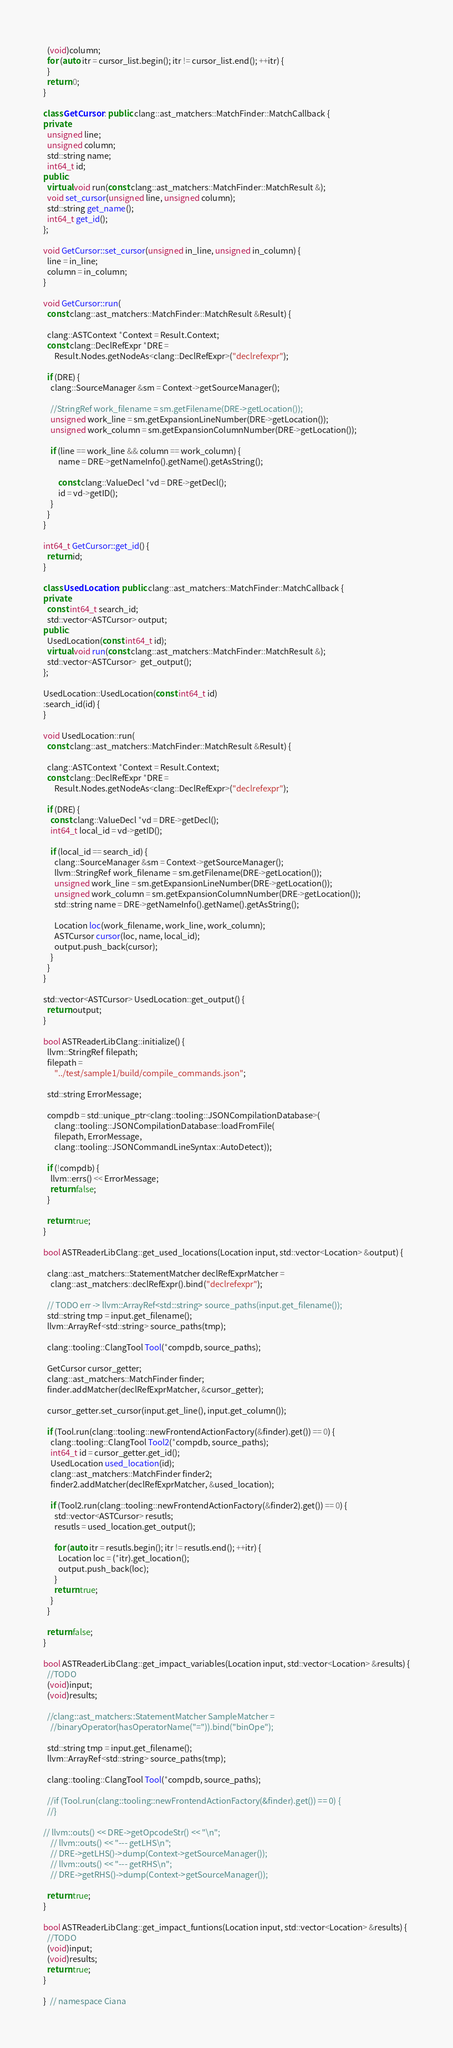Convert code to text. <code><loc_0><loc_0><loc_500><loc_500><_C++_>  (void)column;
  for (auto itr = cursor_list.begin(); itr != cursor_list.end(); ++itr) {
  }
  return 0;
}

class GetCursor : public clang::ast_matchers::MatchFinder::MatchCallback {
private:
  unsigned line;
  unsigned column;
  std::string name;
  int64_t id;
public:
  virtual void run(const clang::ast_matchers::MatchFinder::MatchResult &);
  void set_cursor(unsigned line, unsigned column);
  std::string get_name();
  int64_t get_id();
};

void GetCursor::set_cursor(unsigned in_line, unsigned in_column) {
  line = in_line;
  column = in_column;
}

void GetCursor::run(
  const clang::ast_matchers::MatchFinder::MatchResult &Result) {

  clang::ASTContext *Context = Result.Context;
  const clang::DeclRefExpr *DRE =
      Result.Nodes.getNodeAs<clang::DeclRefExpr>("declrefexpr");

  if (DRE) {
    clang::SourceManager &sm = Context->getSourceManager();

    //StringRef work_filename = sm.getFilename(DRE->getLocation());
    unsigned work_line = sm.getExpansionLineNumber(DRE->getLocation());
    unsigned work_column = sm.getExpansionColumnNumber(DRE->getLocation());

    if (line == work_line && column == work_column) {
        name = DRE->getNameInfo().getName().getAsString();

        const clang::ValueDecl *vd = DRE->getDecl();
        id = vd->getID();
    }
  }
}

int64_t GetCursor::get_id() {
  return id;
}

class UsedLocation : public clang::ast_matchers::MatchFinder::MatchCallback {
private:
  const int64_t search_id;
  std::vector<ASTCursor> output;
public:
  UsedLocation(const int64_t id);
  virtual void run(const clang::ast_matchers::MatchFinder::MatchResult &);
  std::vector<ASTCursor>  get_output();
};

UsedLocation::UsedLocation(const int64_t id)
:search_id(id) { 
}

void UsedLocation::run(
  const clang::ast_matchers::MatchFinder::MatchResult &Result) {

  clang::ASTContext *Context = Result.Context;
  const clang::DeclRefExpr *DRE =
      Result.Nodes.getNodeAs<clang::DeclRefExpr>("declrefexpr");

  if (DRE) {
    const clang::ValueDecl *vd = DRE->getDecl();
    int64_t local_id = vd->getID();

    if (local_id == search_id) {
      clang::SourceManager &sm = Context->getSourceManager();
      llvm::StringRef work_filename = sm.getFilename(DRE->getLocation());
      unsigned work_line = sm.getExpansionLineNumber(DRE->getLocation());
      unsigned work_column = sm.getExpansionColumnNumber(DRE->getLocation());
      std::string name = DRE->getNameInfo().getName().getAsString();

      Location loc(work_filename, work_line, work_column);
      ASTCursor cursor(loc, name, local_id);
      output.push_back(cursor);
    }
  }
}

std::vector<ASTCursor> UsedLocation::get_output() {
  return output;
}

bool ASTReaderLibClang::initialize() {
  llvm::StringRef filepath;
  filepath =
      "../test/sample1/build/compile_commands.json";

  std::string ErrorMessage;

  compdb = std::unique_ptr<clang::tooling::JSONCompilationDatabase>(
      clang::tooling::JSONCompilationDatabase::loadFromFile(
      filepath, ErrorMessage,
      clang::tooling::JSONCommandLineSyntax::AutoDetect));

  if (!compdb) {
    llvm::errs() << ErrorMessage;
    return false;
  }

  return true;
}

bool ASTReaderLibClang::get_used_locations(Location input, std::vector<Location> &output) {

  clang::ast_matchers::StatementMatcher declRefExprMatcher =
    clang::ast_matchers::declRefExpr().bind("declrefexpr");

  // TODO err -> llvm::ArrayRef<std::string> source_paths(input.get_filename());
  std::string tmp = input.get_filename();
  llvm::ArrayRef<std::string> source_paths(tmp);
  
  clang::tooling::ClangTool Tool(*compdb, source_paths);

  GetCursor cursor_getter;
  clang::ast_matchers::MatchFinder finder;
  finder.addMatcher(declRefExprMatcher, &cursor_getter);

  cursor_getter.set_cursor(input.get_line(), input.get_column());

  if (Tool.run(clang::tooling::newFrontendActionFactory(&finder).get()) == 0) {
    clang::tooling::ClangTool Tool2(*compdb, source_paths);
    int64_t id = cursor_getter.get_id();
    UsedLocation used_location(id);
    clang::ast_matchers::MatchFinder finder2;
    finder2.addMatcher(declRefExprMatcher, &used_location);

    if (Tool2.run(clang::tooling::newFrontendActionFactory(&finder2).get()) == 0) {
      std::vector<ASTCursor> resutls;
      resutls = used_location.get_output();

      for (auto itr = resutls.begin(); itr != resutls.end(); ++itr) {
        Location loc = (*itr).get_location();
        output.push_back(loc);
      }
      return true;
    }
  }

  return false;
}

bool ASTReaderLibClang::get_impact_variables(Location input, std::vector<Location> &results) {
  //TODO
  (void)input;
  (void)results;

  //clang::ast_matchers::StatementMatcher SampleMatcher =
    //binaryOperator(hasOperatorName("=")).bind("binOpe");

  std::string tmp = input.get_filename();
  llvm::ArrayRef<std::string> source_paths(tmp);
  
  clang::tooling::ClangTool Tool(*compdb, source_paths);

  //if (Tool.run(clang::tooling::newFrontendActionFactory(&finder).get()) == 0) {
  //}

// llvm::outs() << DRE->getOpcodeStr() << "\n";
    // llvm::outs() << "--- getLHS\n";
    // DRE->getLHS()->dump(Context->getSourceManager());
    // llvm::outs() << "--- getRHS\n";
    // DRE->getRHS()->dump(Context->getSourceManager());

  return true;
}

bool ASTReaderLibClang::get_impact_funtions(Location input, std::vector<Location> &results) {
  //TODO
  (void)input;
  (void)results;
  return true;
}

}  // namespace Ciana
</code> 